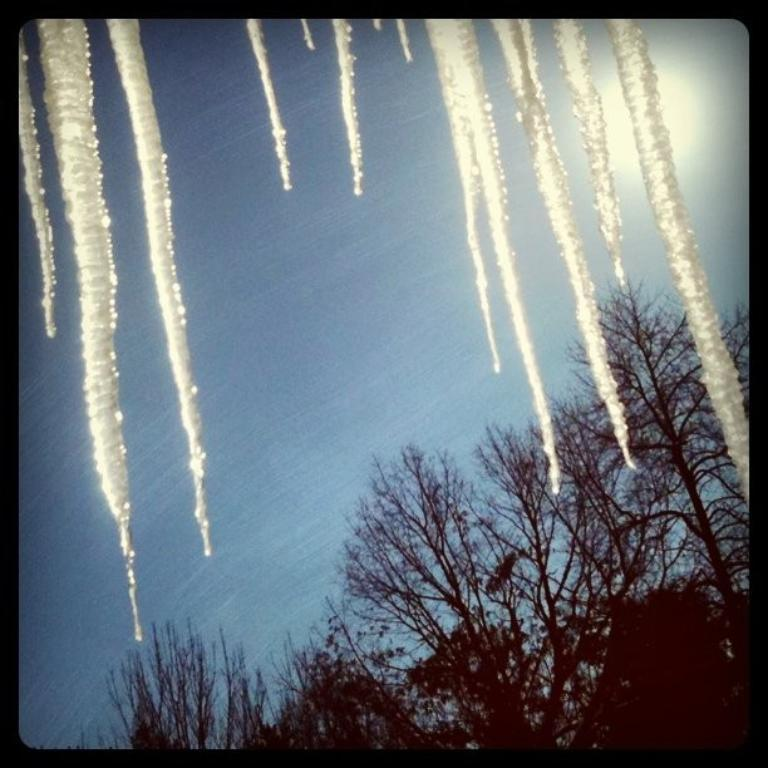What type of structure is present in the image? There is a glass window in the image. What is on the glass window? The glass window has ice on it. What can be seen through the glass window? Trees and the sky are visible through the glass window. What type of pear is hanging from the tree through the glass window? There is no pear visible in the image; only trees and the sky can be seen through the glass window. 